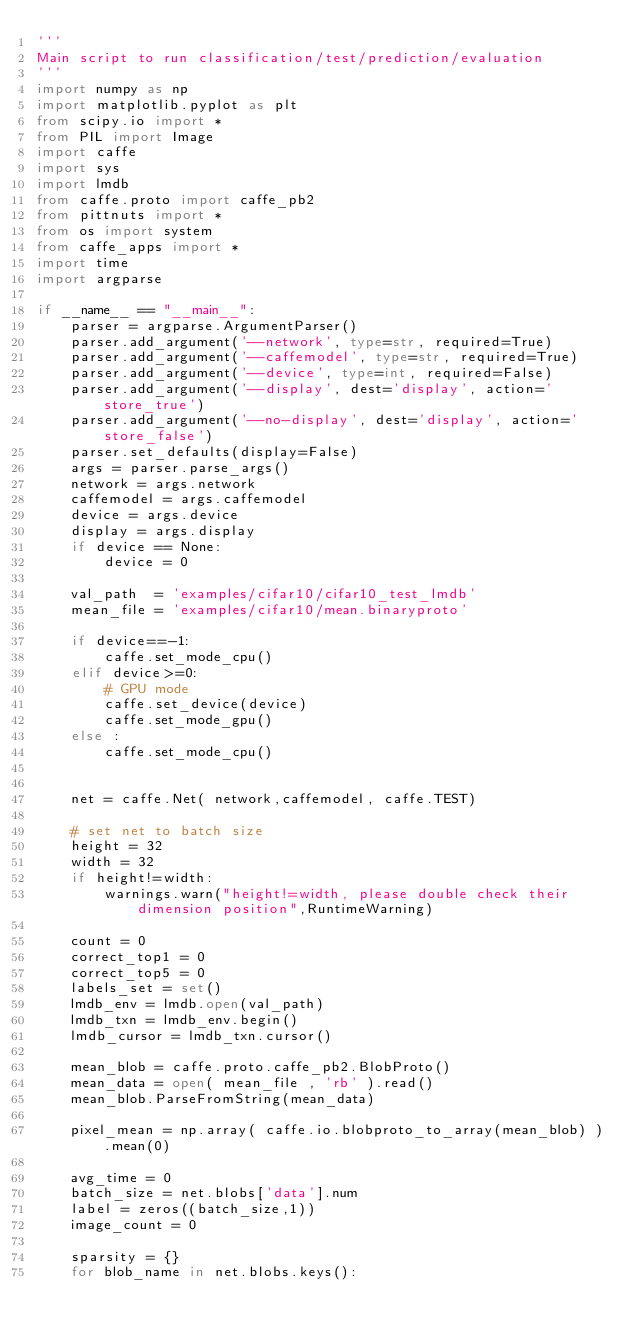<code> <loc_0><loc_0><loc_500><loc_500><_Python_>'''
Main script to run classification/test/prediction/evaluation
'''
import numpy as np
import matplotlib.pyplot as plt
from scipy.io import *
from PIL import Image
import caffe
import sys
import lmdb
from caffe.proto import caffe_pb2
from pittnuts import *
from os import system
from caffe_apps import *
import time
import argparse

if __name__ == "__main__":
    parser = argparse.ArgumentParser()
    parser.add_argument('--network', type=str, required=True)
    parser.add_argument('--caffemodel', type=str, required=True)
    parser.add_argument('--device', type=int, required=False)
    parser.add_argument('--display', dest='display', action='store_true')
    parser.add_argument('--no-display', dest='display', action='store_false')
    parser.set_defaults(display=False)
    args = parser.parse_args()
    network = args.network
    caffemodel = args.caffemodel
    device = args.device
    display = args.display
    if device == None:
        device = 0

    val_path  = 'examples/cifar10/cifar10_test_lmdb'
    mean_file = 'examples/cifar10/mean.binaryproto'

    if device==-1:
        caffe.set_mode_cpu()
    elif device>=0:
        # GPU mode
        caffe.set_device(device)
        caffe.set_mode_gpu()
    else :
        caffe.set_mode_cpu()


    net = caffe.Net( network,caffemodel, caffe.TEST)

    # set net to batch size
    height = 32
    width = 32
    if height!=width:
        warnings.warn("height!=width, please double check their dimension position",RuntimeWarning)

    count = 0
    correct_top1 = 0
    correct_top5 = 0
    labels_set = set()
    lmdb_env = lmdb.open(val_path)
    lmdb_txn = lmdb_env.begin()
    lmdb_cursor = lmdb_txn.cursor()

    mean_blob = caffe.proto.caffe_pb2.BlobProto()
    mean_data = open( mean_file , 'rb' ).read()
    mean_blob.ParseFromString(mean_data)

    pixel_mean = np.array( caffe.io.blobproto_to_array(mean_blob) ).mean(0)

    avg_time = 0
    batch_size = net.blobs['data'].num
    label = zeros((batch_size,1))
    image_count = 0

    sparsity = {}
    for blob_name in net.blobs.keys():</code> 